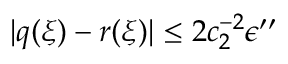<formula> <loc_0><loc_0><loc_500><loc_500>| q ( \xi ) - r ( \xi ) | \leq 2 c _ { 2 } ^ { - 2 } \epsilon ^ { \prime \prime }</formula> 